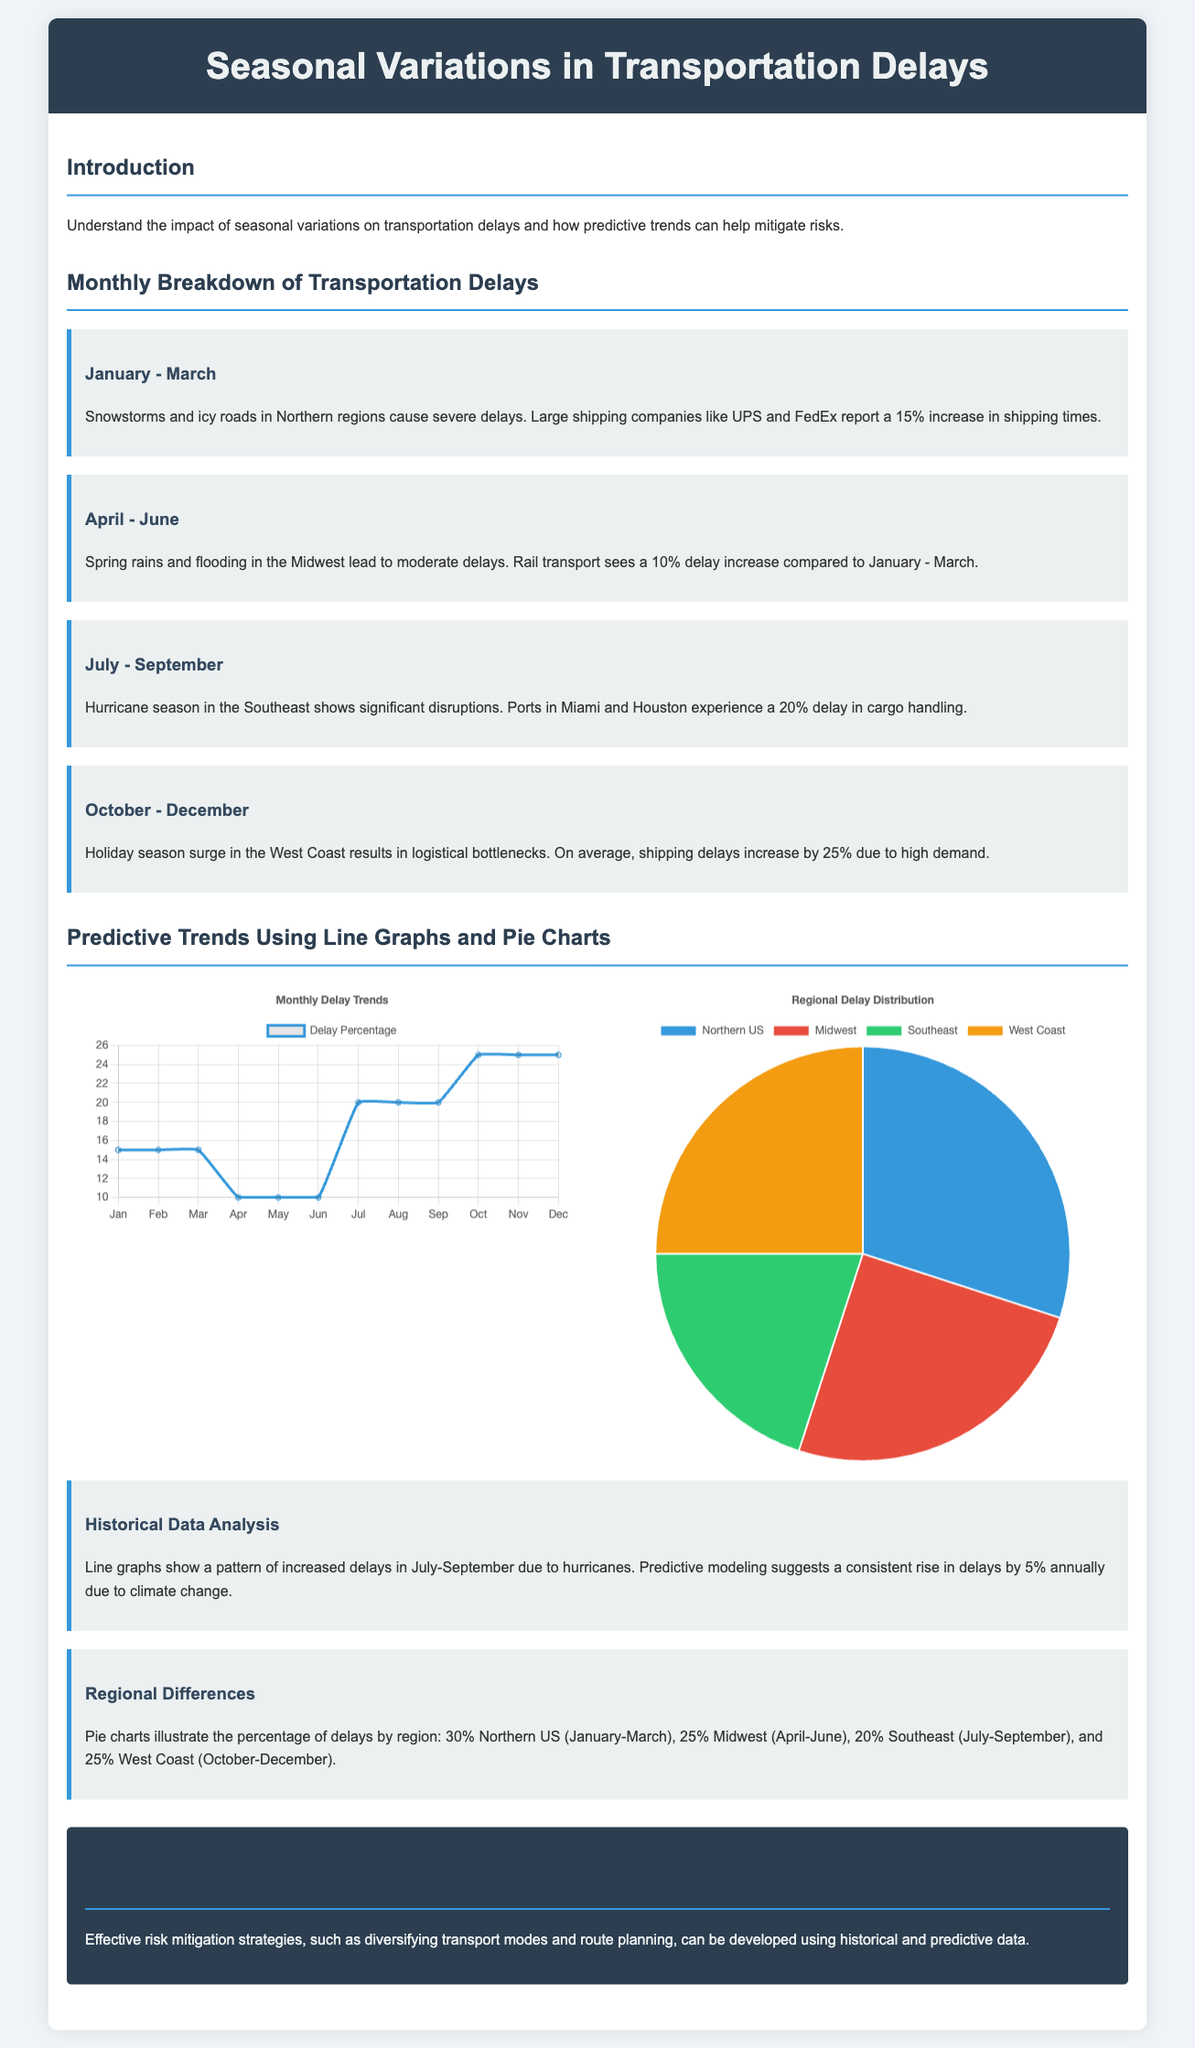What is the primary focus of the infographic? The infographic focuses on understanding the impact of seasonal variations on transportation delays and how predictive trends can help mitigate risks.
Answer: Seasonal variations in transportation delays What is the percentage increase in shipping times reported by large shipping companies from January to March? The document states that large shipping companies report a 15% increase in shipping times during this period.
Answer: 15% Which month shows the highest delay percentage according to the line graph? The line graph indicates that October to December shows the highest shipping delays of 25%.
Answer: October to December What is the percentage of delays attributed to the Northern US? The pie chart illustrates that 30% of delays are attributed to the Northern US.
Answer: 30% What major weather event is indicated to cause significant disruptions in the Southeast from July to September? The document highlights that hurricanes cause significant disruptions in the Southeast during this period.
Answer: Hurricanes How much do delays increase annually due to climate change, as suggested by predictive modeling? The predictive modeling suggests that delays increase by 5% annually due to climate change.
Answer: 5% What is a suggested risk mitigation strategy mentioned in the conclusion? The conclusion mentions diversifying transport modes as a suggested risk mitigation strategy.
Answer: Diversifying transport modes Which region experiences a 20% delay in cargo handling during the July-September period? The document specifies that ports in Miami and Houston experience a 20% delay in cargo handling during this period.
Answer: Southeast What does the pie chart represent in the context of transportation delays? The pie chart represents the percentage of delays by region.
Answer: Percentage of delays by region 